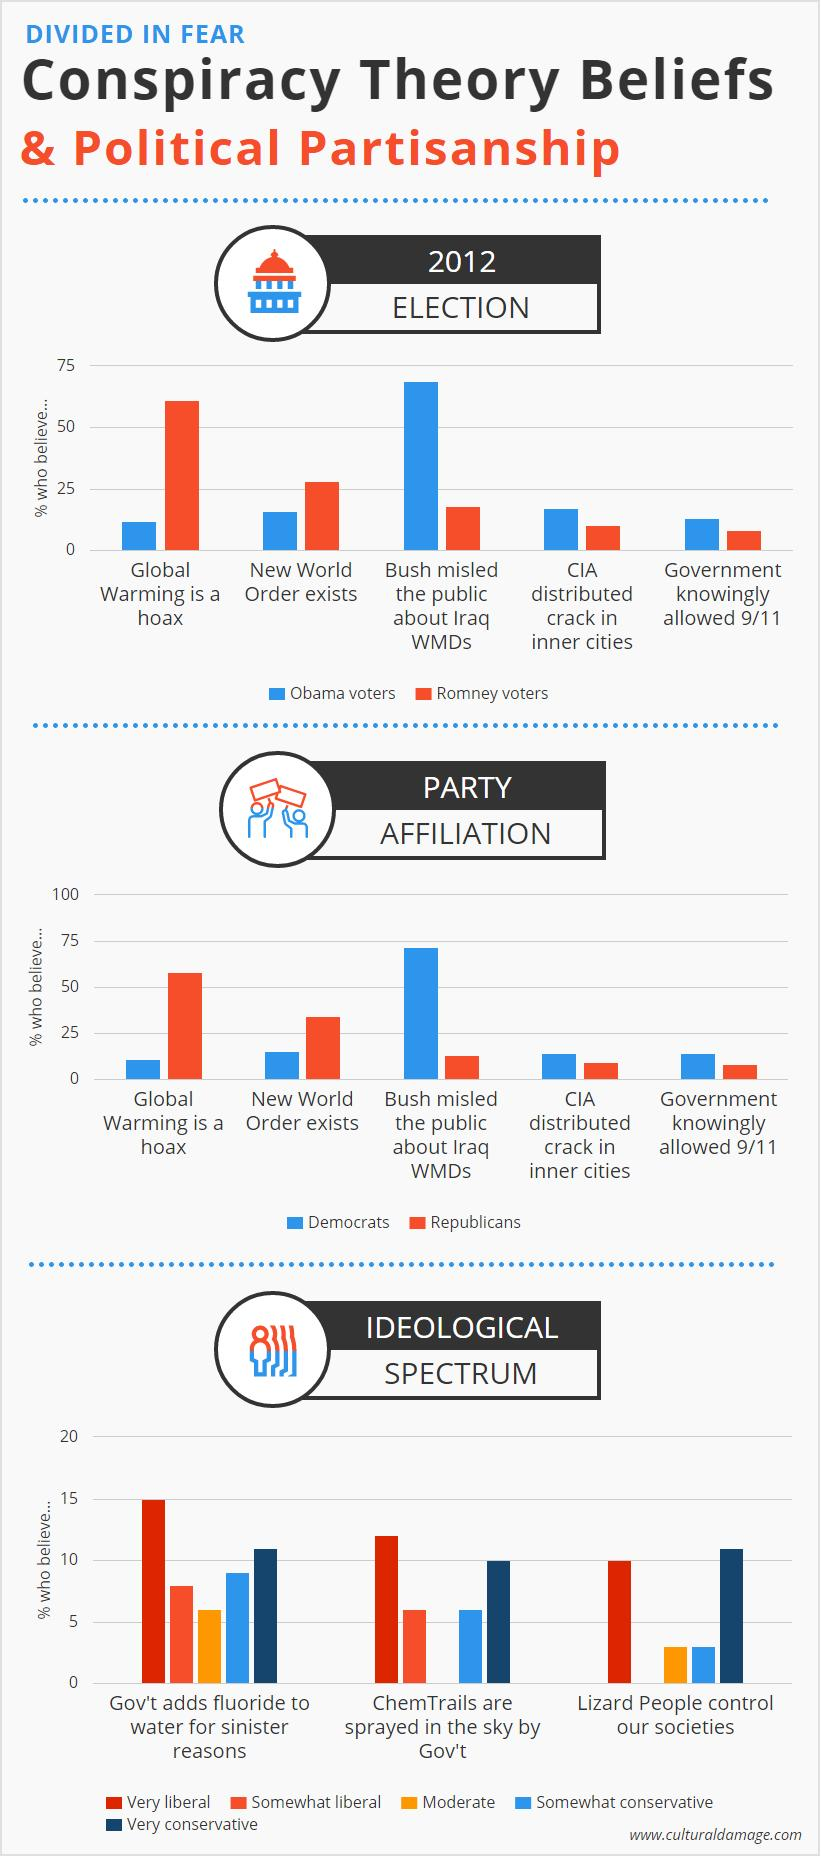Indicate a few pertinent items in this graphic. A majority of individuals who believe that global warming is a hoax identify as Romney voters. According to a recent survey, 15% of very liberal individuals believe that the government adds fluoride to their drinking water. 10% of the ideology believes that lizard people control our societies, and they are very liberal. 10% of very conservative people believe that chemtrails are sprayed in the sky by the government. I strongly believe that lizard people secretly control our societies. 